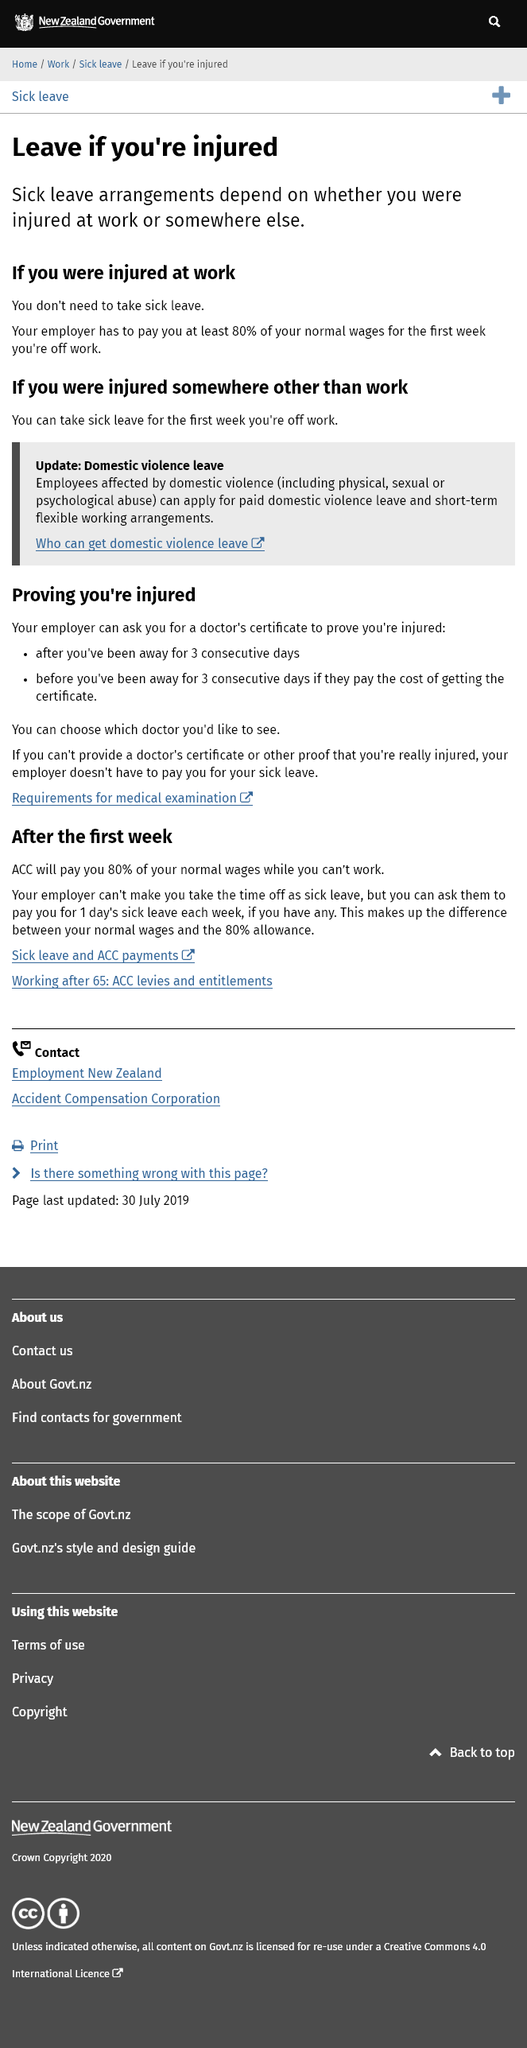Indicate a few pertinent items in this graphic. Aside from domestic violence leave, there are two arrangements for taking leave if an employee is injured. If you are injured somewhere other than work, you are entitled to a week-long sick leave, according to the information provided. You are entitled to at least 80% of your normal wage for the first week of leave if you are injured at work. 